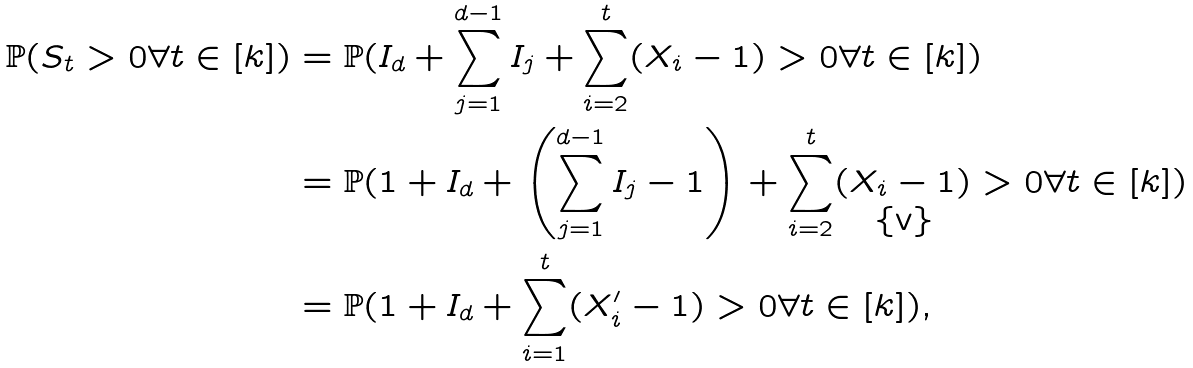<formula> <loc_0><loc_0><loc_500><loc_500>\mathbb { P } ( S _ { t } > 0 \forall t \in [ k ] ) & = \mathbb { P } ( I _ { d } + \sum _ { j = 1 } ^ { d - 1 } I _ { j } + \sum _ { i = 2 } ^ { t } ( X _ { i } - 1 ) > 0 \forall t \in [ k ] ) \\ & = \mathbb { P } ( 1 + I _ { d } + \left ( \sum _ { j = 1 } ^ { d - 1 } I _ { j } - 1 \right ) + \sum _ { i = 2 } ^ { t } ( X _ { i } - 1 ) > 0 \forall t \in [ k ] ) \\ & = \mathbb { P } ( 1 + I _ { d } + \sum _ { i = 1 } ^ { t } ( X ^ { \prime } _ { i } - 1 ) > 0 \forall t \in [ k ] ) ,</formula> 